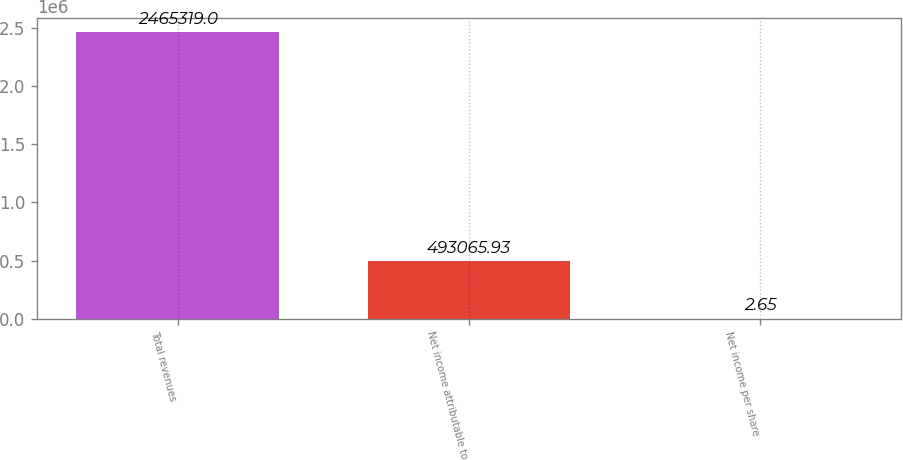Convert chart. <chart><loc_0><loc_0><loc_500><loc_500><bar_chart><fcel>Total revenues<fcel>Net income attributable to<fcel>Net income per share<nl><fcel>2.46532e+06<fcel>493066<fcel>2.65<nl></chart> 